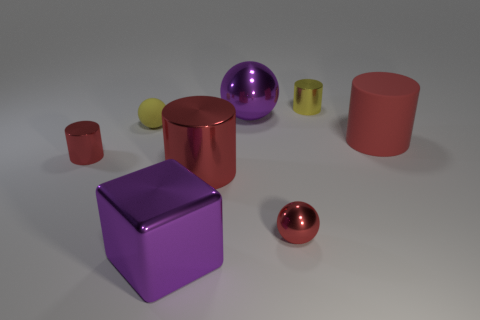Is there anything else that has the same material as the purple cube?
Provide a short and direct response. Yes. What number of large things are red metal balls or yellow metal things?
Keep it short and to the point. 0. There is a large red object to the left of the red matte object; is it the same shape as the yellow rubber object?
Your response must be concise. No. Is the number of red spheres less than the number of small brown matte cylinders?
Your response must be concise. No. Are there any other things that are the same color as the small rubber ball?
Ensure brevity in your answer.  Yes. There is a shiny thing in front of the tiny red sphere; what shape is it?
Make the answer very short. Cube. Does the cube have the same color as the tiny metallic object left of the cube?
Make the answer very short. No. Are there an equal number of shiny objects that are in front of the tiny yellow rubber ball and tiny red objects that are on the right side of the big red rubber object?
Offer a terse response. No. How many other objects are the same size as the yellow cylinder?
Your response must be concise. 3. What is the size of the yellow metal thing?
Your answer should be compact. Small. 